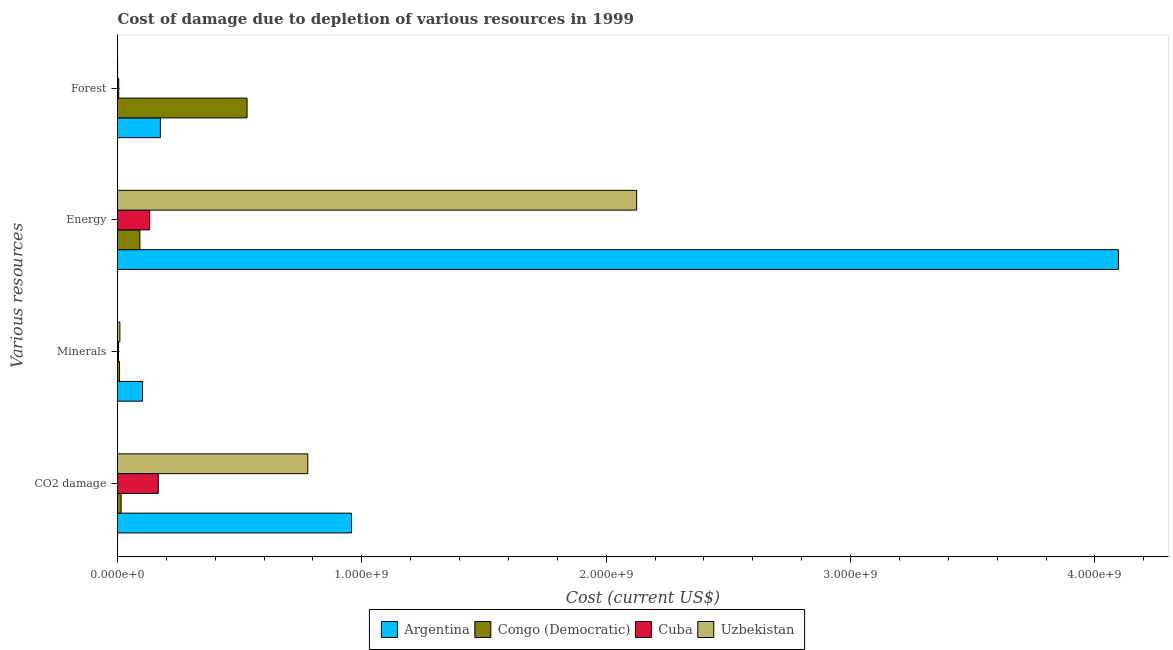How many groups of bars are there?
Make the answer very short. 4. What is the label of the 4th group of bars from the top?
Your answer should be compact. CO2 damage. What is the cost of damage due to depletion of forests in Argentina?
Your response must be concise. 1.75e+08. Across all countries, what is the maximum cost of damage due to depletion of minerals?
Provide a succinct answer. 1.03e+08. Across all countries, what is the minimum cost of damage due to depletion of forests?
Your response must be concise. 3.57e+05. In which country was the cost of damage due to depletion of coal minimum?
Ensure brevity in your answer.  Congo (Democratic). What is the total cost of damage due to depletion of forests in the graph?
Keep it short and to the point. 7.11e+08. What is the difference between the cost of damage due to depletion of energy in Argentina and that in Congo (Democratic)?
Your answer should be very brief. 4.00e+09. What is the difference between the cost of damage due to depletion of coal in Congo (Democratic) and the cost of damage due to depletion of energy in Argentina?
Provide a short and direct response. -4.08e+09. What is the average cost of damage due to depletion of minerals per country?
Make the answer very short. 3.12e+07. What is the difference between the cost of damage due to depletion of energy and cost of damage due to depletion of coal in Uzbekistan?
Offer a very short reply. 1.35e+09. What is the ratio of the cost of damage due to depletion of forests in Uzbekistan to that in Congo (Democratic)?
Give a very brief answer. 0. Is the cost of damage due to depletion of energy in Cuba less than that in Uzbekistan?
Your answer should be very brief. Yes. What is the difference between the highest and the second highest cost of damage due to depletion of coal?
Your answer should be very brief. 1.79e+08. What is the difference between the highest and the lowest cost of damage due to depletion of energy?
Your answer should be very brief. 4.00e+09. What does the 3rd bar from the top in CO2 damage represents?
Make the answer very short. Congo (Democratic). What does the 3rd bar from the bottom in Minerals represents?
Provide a short and direct response. Cuba. How many bars are there?
Keep it short and to the point. 16. Are all the bars in the graph horizontal?
Give a very brief answer. Yes. What is the difference between two consecutive major ticks on the X-axis?
Your answer should be very brief. 1.00e+09. Does the graph contain grids?
Provide a short and direct response. No. Where does the legend appear in the graph?
Give a very brief answer. Bottom center. How are the legend labels stacked?
Ensure brevity in your answer.  Horizontal. What is the title of the graph?
Your response must be concise. Cost of damage due to depletion of various resources in 1999 . What is the label or title of the X-axis?
Make the answer very short. Cost (current US$). What is the label or title of the Y-axis?
Give a very brief answer. Various resources. What is the Cost (current US$) in Argentina in CO2 damage?
Offer a terse response. 9.58e+08. What is the Cost (current US$) in Congo (Democratic) in CO2 damage?
Keep it short and to the point. 1.48e+07. What is the Cost (current US$) in Cuba in CO2 damage?
Your answer should be compact. 1.67e+08. What is the Cost (current US$) of Uzbekistan in CO2 damage?
Give a very brief answer. 7.79e+08. What is the Cost (current US$) of Argentina in Minerals?
Your answer should be very brief. 1.03e+08. What is the Cost (current US$) of Congo (Democratic) in Minerals?
Keep it short and to the point. 8.26e+06. What is the Cost (current US$) of Cuba in Minerals?
Keep it short and to the point. 4.16e+06. What is the Cost (current US$) of Uzbekistan in Minerals?
Provide a succinct answer. 9.72e+06. What is the Cost (current US$) in Argentina in Energy?
Keep it short and to the point. 4.10e+09. What is the Cost (current US$) in Congo (Democratic) in Energy?
Your response must be concise. 9.16e+07. What is the Cost (current US$) of Cuba in Energy?
Keep it short and to the point. 1.32e+08. What is the Cost (current US$) in Uzbekistan in Energy?
Keep it short and to the point. 2.12e+09. What is the Cost (current US$) of Argentina in Forest?
Keep it short and to the point. 1.75e+08. What is the Cost (current US$) of Congo (Democratic) in Forest?
Ensure brevity in your answer.  5.30e+08. What is the Cost (current US$) of Cuba in Forest?
Your response must be concise. 4.96e+06. What is the Cost (current US$) in Uzbekistan in Forest?
Your response must be concise. 3.57e+05. Across all Various resources, what is the maximum Cost (current US$) of Argentina?
Keep it short and to the point. 4.10e+09. Across all Various resources, what is the maximum Cost (current US$) in Congo (Democratic)?
Offer a very short reply. 5.30e+08. Across all Various resources, what is the maximum Cost (current US$) in Cuba?
Provide a succinct answer. 1.67e+08. Across all Various resources, what is the maximum Cost (current US$) in Uzbekistan?
Make the answer very short. 2.12e+09. Across all Various resources, what is the minimum Cost (current US$) of Argentina?
Your response must be concise. 1.03e+08. Across all Various resources, what is the minimum Cost (current US$) of Congo (Democratic)?
Keep it short and to the point. 8.26e+06. Across all Various resources, what is the minimum Cost (current US$) of Cuba?
Provide a succinct answer. 4.16e+06. Across all Various resources, what is the minimum Cost (current US$) in Uzbekistan?
Make the answer very short. 3.57e+05. What is the total Cost (current US$) of Argentina in the graph?
Provide a short and direct response. 5.33e+09. What is the total Cost (current US$) in Congo (Democratic) in the graph?
Provide a succinct answer. 6.45e+08. What is the total Cost (current US$) of Cuba in the graph?
Provide a short and direct response. 3.08e+08. What is the total Cost (current US$) in Uzbekistan in the graph?
Provide a short and direct response. 2.91e+09. What is the difference between the Cost (current US$) of Argentina in CO2 damage and that in Minerals?
Offer a very short reply. 8.55e+08. What is the difference between the Cost (current US$) of Congo (Democratic) in CO2 damage and that in Minerals?
Provide a short and direct response. 6.53e+06. What is the difference between the Cost (current US$) in Cuba in CO2 damage and that in Minerals?
Your response must be concise. 1.63e+08. What is the difference between the Cost (current US$) in Uzbekistan in CO2 damage and that in Minerals?
Keep it short and to the point. 7.69e+08. What is the difference between the Cost (current US$) of Argentina in CO2 damage and that in Energy?
Make the answer very short. -3.14e+09. What is the difference between the Cost (current US$) of Congo (Democratic) in CO2 damage and that in Energy?
Make the answer very short. -7.68e+07. What is the difference between the Cost (current US$) in Cuba in CO2 damage and that in Energy?
Offer a terse response. 3.50e+07. What is the difference between the Cost (current US$) of Uzbekistan in CO2 damage and that in Energy?
Give a very brief answer. -1.35e+09. What is the difference between the Cost (current US$) of Argentina in CO2 damage and that in Forest?
Provide a succinct answer. 7.82e+08. What is the difference between the Cost (current US$) in Congo (Democratic) in CO2 damage and that in Forest?
Keep it short and to the point. -5.15e+08. What is the difference between the Cost (current US$) of Cuba in CO2 damage and that in Forest?
Provide a succinct answer. 1.62e+08. What is the difference between the Cost (current US$) of Uzbekistan in CO2 damage and that in Forest?
Keep it short and to the point. 7.78e+08. What is the difference between the Cost (current US$) of Argentina in Minerals and that in Energy?
Keep it short and to the point. -3.99e+09. What is the difference between the Cost (current US$) in Congo (Democratic) in Minerals and that in Energy?
Your answer should be compact. -8.34e+07. What is the difference between the Cost (current US$) of Cuba in Minerals and that in Energy?
Provide a succinct answer. -1.28e+08. What is the difference between the Cost (current US$) of Uzbekistan in Minerals and that in Energy?
Your answer should be compact. -2.11e+09. What is the difference between the Cost (current US$) in Argentina in Minerals and that in Forest?
Ensure brevity in your answer.  -7.28e+07. What is the difference between the Cost (current US$) of Congo (Democratic) in Minerals and that in Forest?
Provide a succinct answer. -5.22e+08. What is the difference between the Cost (current US$) of Cuba in Minerals and that in Forest?
Ensure brevity in your answer.  -8.07e+05. What is the difference between the Cost (current US$) of Uzbekistan in Minerals and that in Forest?
Your answer should be very brief. 9.36e+06. What is the difference between the Cost (current US$) in Argentina in Energy and that in Forest?
Your response must be concise. 3.92e+09. What is the difference between the Cost (current US$) of Congo (Democratic) in Energy and that in Forest?
Ensure brevity in your answer.  -4.39e+08. What is the difference between the Cost (current US$) of Cuba in Energy and that in Forest?
Provide a succinct answer. 1.27e+08. What is the difference between the Cost (current US$) of Uzbekistan in Energy and that in Forest?
Keep it short and to the point. 2.12e+09. What is the difference between the Cost (current US$) of Argentina in CO2 damage and the Cost (current US$) of Congo (Democratic) in Minerals?
Offer a very short reply. 9.49e+08. What is the difference between the Cost (current US$) of Argentina in CO2 damage and the Cost (current US$) of Cuba in Minerals?
Your answer should be compact. 9.53e+08. What is the difference between the Cost (current US$) in Argentina in CO2 damage and the Cost (current US$) in Uzbekistan in Minerals?
Provide a short and direct response. 9.48e+08. What is the difference between the Cost (current US$) of Congo (Democratic) in CO2 damage and the Cost (current US$) of Cuba in Minerals?
Provide a short and direct response. 1.06e+07. What is the difference between the Cost (current US$) of Congo (Democratic) in CO2 damage and the Cost (current US$) of Uzbekistan in Minerals?
Provide a short and direct response. 5.07e+06. What is the difference between the Cost (current US$) in Cuba in CO2 damage and the Cost (current US$) in Uzbekistan in Minerals?
Offer a terse response. 1.57e+08. What is the difference between the Cost (current US$) in Argentina in CO2 damage and the Cost (current US$) in Congo (Democratic) in Energy?
Offer a very short reply. 8.66e+08. What is the difference between the Cost (current US$) of Argentina in CO2 damage and the Cost (current US$) of Cuba in Energy?
Give a very brief answer. 8.26e+08. What is the difference between the Cost (current US$) in Argentina in CO2 damage and the Cost (current US$) in Uzbekistan in Energy?
Keep it short and to the point. -1.17e+09. What is the difference between the Cost (current US$) of Congo (Democratic) in CO2 damage and the Cost (current US$) of Cuba in Energy?
Your answer should be compact. -1.17e+08. What is the difference between the Cost (current US$) in Congo (Democratic) in CO2 damage and the Cost (current US$) in Uzbekistan in Energy?
Offer a very short reply. -2.11e+09. What is the difference between the Cost (current US$) of Cuba in CO2 damage and the Cost (current US$) of Uzbekistan in Energy?
Your response must be concise. -1.96e+09. What is the difference between the Cost (current US$) in Argentina in CO2 damage and the Cost (current US$) in Congo (Democratic) in Forest?
Give a very brief answer. 4.27e+08. What is the difference between the Cost (current US$) in Argentina in CO2 damage and the Cost (current US$) in Cuba in Forest?
Your answer should be very brief. 9.53e+08. What is the difference between the Cost (current US$) in Argentina in CO2 damage and the Cost (current US$) in Uzbekistan in Forest?
Offer a terse response. 9.57e+08. What is the difference between the Cost (current US$) in Congo (Democratic) in CO2 damage and the Cost (current US$) in Cuba in Forest?
Ensure brevity in your answer.  9.83e+06. What is the difference between the Cost (current US$) in Congo (Democratic) in CO2 damage and the Cost (current US$) in Uzbekistan in Forest?
Provide a succinct answer. 1.44e+07. What is the difference between the Cost (current US$) in Cuba in CO2 damage and the Cost (current US$) in Uzbekistan in Forest?
Give a very brief answer. 1.66e+08. What is the difference between the Cost (current US$) in Argentina in Minerals and the Cost (current US$) in Congo (Democratic) in Energy?
Ensure brevity in your answer.  1.10e+07. What is the difference between the Cost (current US$) of Argentina in Minerals and the Cost (current US$) of Cuba in Energy?
Ensure brevity in your answer.  -2.91e+07. What is the difference between the Cost (current US$) in Argentina in Minerals and the Cost (current US$) in Uzbekistan in Energy?
Provide a succinct answer. -2.02e+09. What is the difference between the Cost (current US$) of Congo (Democratic) in Minerals and the Cost (current US$) of Cuba in Energy?
Provide a short and direct response. -1.23e+08. What is the difference between the Cost (current US$) of Congo (Democratic) in Minerals and the Cost (current US$) of Uzbekistan in Energy?
Your response must be concise. -2.12e+09. What is the difference between the Cost (current US$) of Cuba in Minerals and the Cost (current US$) of Uzbekistan in Energy?
Your answer should be compact. -2.12e+09. What is the difference between the Cost (current US$) in Argentina in Minerals and the Cost (current US$) in Congo (Democratic) in Forest?
Provide a succinct answer. -4.28e+08. What is the difference between the Cost (current US$) of Argentina in Minerals and the Cost (current US$) of Cuba in Forest?
Provide a short and direct response. 9.77e+07. What is the difference between the Cost (current US$) of Argentina in Minerals and the Cost (current US$) of Uzbekistan in Forest?
Your response must be concise. 1.02e+08. What is the difference between the Cost (current US$) of Congo (Democratic) in Minerals and the Cost (current US$) of Cuba in Forest?
Provide a short and direct response. 3.30e+06. What is the difference between the Cost (current US$) of Congo (Democratic) in Minerals and the Cost (current US$) of Uzbekistan in Forest?
Your response must be concise. 7.90e+06. What is the difference between the Cost (current US$) of Cuba in Minerals and the Cost (current US$) of Uzbekistan in Forest?
Offer a very short reply. 3.80e+06. What is the difference between the Cost (current US$) in Argentina in Energy and the Cost (current US$) in Congo (Democratic) in Forest?
Your answer should be very brief. 3.57e+09. What is the difference between the Cost (current US$) in Argentina in Energy and the Cost (current US$) in Cuba in Forest?
Keep it short and to the point. 4.09e+09. What is the difference between the Cost (current US$) in Argentina in Energy and the Cost (current US$) in Uzbekistan in Forest?
Ensure brevity in your answer.  4.10e+09. What is the difference between the Cost (current US$) in Congo (Democratic) in Energy and the Cost (current US$) in Cuba in Forest?
Your response must be concise. 8.67e+07. What is the difference between the Cost (current US$) in Congo (Democratic) in Energy and the Cost (current US$) in Uzbekistan in Forest?
Provide a succinct answer. 9.13e+07. What is the difference between the Cost (current US$) of Cuba in Energy and the Cost (current US$) of Uzbekistan in Forest?
Provide a succinct answer. 1.31e+08. What is the average Cost (current US$) of Argentina per Various resources?
Your response must be concise. 1.33e+09. What is the average Cost (current US$) in Congo (Democratic) per Various resources?
Ensure brevity in your answer.  1.61e+08. What is the average Cost (current US$) in Cuba per Various resources?
Provide a short and direct response. 7.69e+07. What is the average Cost (current US$) in Uzbekistan per Various resources?
Provide a succinct answer. 7.28e+08. What is the difference between the Cost (current US$) of Argentina and Cost (current US$) of Congo (Democratic) in CO2 damage?
Your answer should be compact. 9.43e+08. What is the difference between the Cost (current US$) of Argentina and Cost (current US$) of Cuba in CO2 damage?
Provide a succinct answer. 7.91e+08. What is the difference between the Cost (current US$) of Argentina and Cost (current US$) of Uzbekistan in CO2 damage?
Your answer should be compact. 1.79e+08. What is the difference between the Cost (current US$) of Congo (Democratic) and Cost (current US$) of Cuba in CO2 damage?
Your response must be concise. -1.52e+08. What is the difference between the Cost (current US$) of Congo (Democratic) and Cost (current US$) of Uzbekistan in CO2 damage?
Offer a very short reply. -7.64e+08. What is the difference between the Cost (current US$) of Cuba and Cost (current US$) of Uzbekistan in CO2 damage?
Provide a short and direct response. -6.12e+08. What is the difference between the Cost (current US$) in Argentina and Cost (current US$) in Congo (Democratic) in Minerals?
Give a very brief answer. 9.44e+07. What is the difference between the Cost (current US$) of Argentina and Cost (current US$) of Cuba in Minerals?
Make the answer very short. 9.85e+07. What is the difference between the Cost (current US$) in Argentina and Cost (current US$) in Uzbekistan in Minerals?
Keep it short and to the point. 9.29e+07. What is the difference between the Cost (current US$) of Congo (Democratic) and Cost (current US$) of Cuba in Minerals?
Your answer should be compact. 4.10e+06. What is the difference between the Cost (current US$) in Congo (Democratic) and Cost (current US$) in Uzbekistan in Minerals?
Offer a terse response. -1.46e+06. What is the difference between the Cost (current US$) in Cuba and Cost (current US$) in Uzbekistan in Minerals?
Make the answer very short. -5.56e+06. What is the difference between the Cost (current US$) in Argentina and Cost (current US$) in Congo (Democratic) in Energy?
Provide a succinct answer. 4.00e+09. What is the difference between the Cost (current US$) in Argentina and Cost (current US$) in Cuba in Energy?
Provide a succinct answer. 3.96e+09. What is the difference between the Cost (current US$) of Argentina and Cost (current US$) of Uzbekistan in Energy?
Your answer should be compact. 1.97e+09. What is the difference between the Cost (current US$) in Congo (Democratic) and Cost (current US$) in Cuba in Energy?
Provide a short and direct response. -4.01e+07. What is the difference between the Cost (current US$) of Congo (Democratic) and Cost (current US$) of Uzbekistan in Energy?
Keep it short and to the point. -2.03e+09. What is the difference between the Cost (current US$) in Cuba and Cost (current US$) in Uzbekistan in Energy?
Your answer should be very brief. -1.99e+09. What is the difference between the Cost (current US$) of Argentina and Cost (current US$) of Congo (Democratic) in Forest?
Offer a terse response. -3.55e+08. What is the difference between the Cost (current US$) in Argentina and Cost (current US$) in Cuba in Forest?
Give a very brief answer. 1.71e+08. What is the difference between the Cost (current US$) in Argentina and Cost (current US$) in Uzbekistan in Forest?
Keep it short and to the point. 1.75e+08. What is the difference between the Cost (current US$) in Congo (Democratic) and Cost (current US$) in Cuba in Forest?
Your answer should be very brief. 5.25e+08. What is the difference between the Cost (current US$) of Congo (Democratic) and Cost (current US$) of Uzbekistan in Forest?
Provide a short and direct response. 5.30e+08. What is the difference between the Cost (current US$) of Cuba and Cost (current US$) of Uzbekistan in Forest?
Make the answer very short. 4.61e+06. What is the ratio of the Cost (current US$) of Argentina in CO2 damage to that in Minerals?
Your answer should be very brief. 9.33. What is the ratio of the Cost (current US$) of Congo (Democratic) in CO2 damage to that in Minerals?
Provide a short and direct response. 1.79. What is the ratio of the Cost (current US$) of Cuba in CO2 damage to that in Minerals?
Provide a short and direct response. 40.1. What is the ratio of the Cost (current US$) of Uzbekistan in CO2 damage to that in Minerals?
Offer a very short reply. 80.12. What is the ratio of the Cost (current US$) in Argentina in CO2 damage to that in Energy?
Give a very brief answer. 0.23. What is the ratio of the Cost (current US$) in Congo (Democratic) in CO2 damage to that in Energy?
Give a very brief answer. 0.16. What is the ratio of the Cost (current US$) of Cuba in CO2 damage to that in Energy?
Offer a very short reply. 1.27. What is the ratio of the Cost (current US$) of Uzbekistan in CO2 damage to that in Energy?
Keep it short and to the point. 0.37. What is the ratio of the Cost (current US$) in Argentina in CO2 damage to that in Forest?
Your answer should be compact. 5.46. What is the ratio of the Cost (current US$) of Congo (Democratic) in CO2 damage to that in Forest?
Provide a short and direct response. 0.03. What is the ratio of the Cost (current US$) of Cuba in CO2 damage to that in Forest?
Keep it short and to the point. 33.59. What is the ratio of the Cost (current US$) in Uzbekistan in CO2 damage to that in Forest?
Your answer should be very brief. 2178.7. What is the ratio of the Cost (current US$) in Argentina in Minerals to that in Energy?
Offer a very short reply. 0.03. What is the ratio of the Cost (current US$) in Congo (Democratic) in Minerals to that in Energy?
Your answer should be compact. 0.09. What is the ratio of the Cost (current US$) in Cuba in Minerals to that in Energy?
Your answer should be compact. 0.03. What is the ratio of the Cost (current US$) in Uzbekistan in Minerals to that in Energy?
Make the answer very short. 0. What is the ratio of the Cost (current US$) in Argentina in Minerals to that in Forest?
Ensure brevity in your answer.  0.58. What is the ratio of the Cost (current US$) of Congo (Democratic) in Minerals to that in Forest?
Ensure brevity in your answer.  0.02. What is the ratio of the Cost (current US$) in Cuba in Minerals to that in Forest?
Keep it short and to the point. 0.84. What is the ratio of the Cost (current US$) of Uzbekistan in Minerals to that in Forest?
Your answer should be compact. 27.19. What is the ratio of the Cost (current US$) of Argentina in Energy to that in Forest?
Make the answer very short. 23.35. What is the ratio of the Cost (current US$) in Congo (Democratic) in Energy to that in Forest?
Keep it short and to the point. 0.17. What is the ratio of the Cost (current US$) of Cuba in Energy to that in Forest?
Provide a short and direct response. 26.53. What is the ratio of the Cost (current US$) of Uzbekistan in Energy to that in Forest?
Your answer should be very brief. 5943.67. What is the difference between the highest and the second highest Cost (current US$) in Argentina?
Offer a very short reply. 3.14e+09. What is the difference between the highest and the second highest Cost (current US$) of Congo (Democratic)?
Provide a short and direct response. 4.39e+08. What is the difference between the highest and the second highest Cost (current US$) in Cuba?
Ensure brevity in your answer.  3.50e+07. What is the difference between the highest and the second highest Cost (current US$) in Uzbekistan?
Your response must be concise. 1.35e+09. What is the difference between the highest and the lowest Cost (current US$) of Argentina?
Offer a terse response. 3.99e+09. What is the difference between the highest and the lowest Cost (current US$) of Congo (Democratic)?
Offer a terse response. 5.22e+08. What is the difference between the highest and the lowest Cost (current US$) of Cuba?
Provide a succinct answer. 1.63e+08. What is the difference between the highest and the lowest Cost (current US$) in Uzbekistan?
Ensure brevity in your answer.  2.12e+09. 